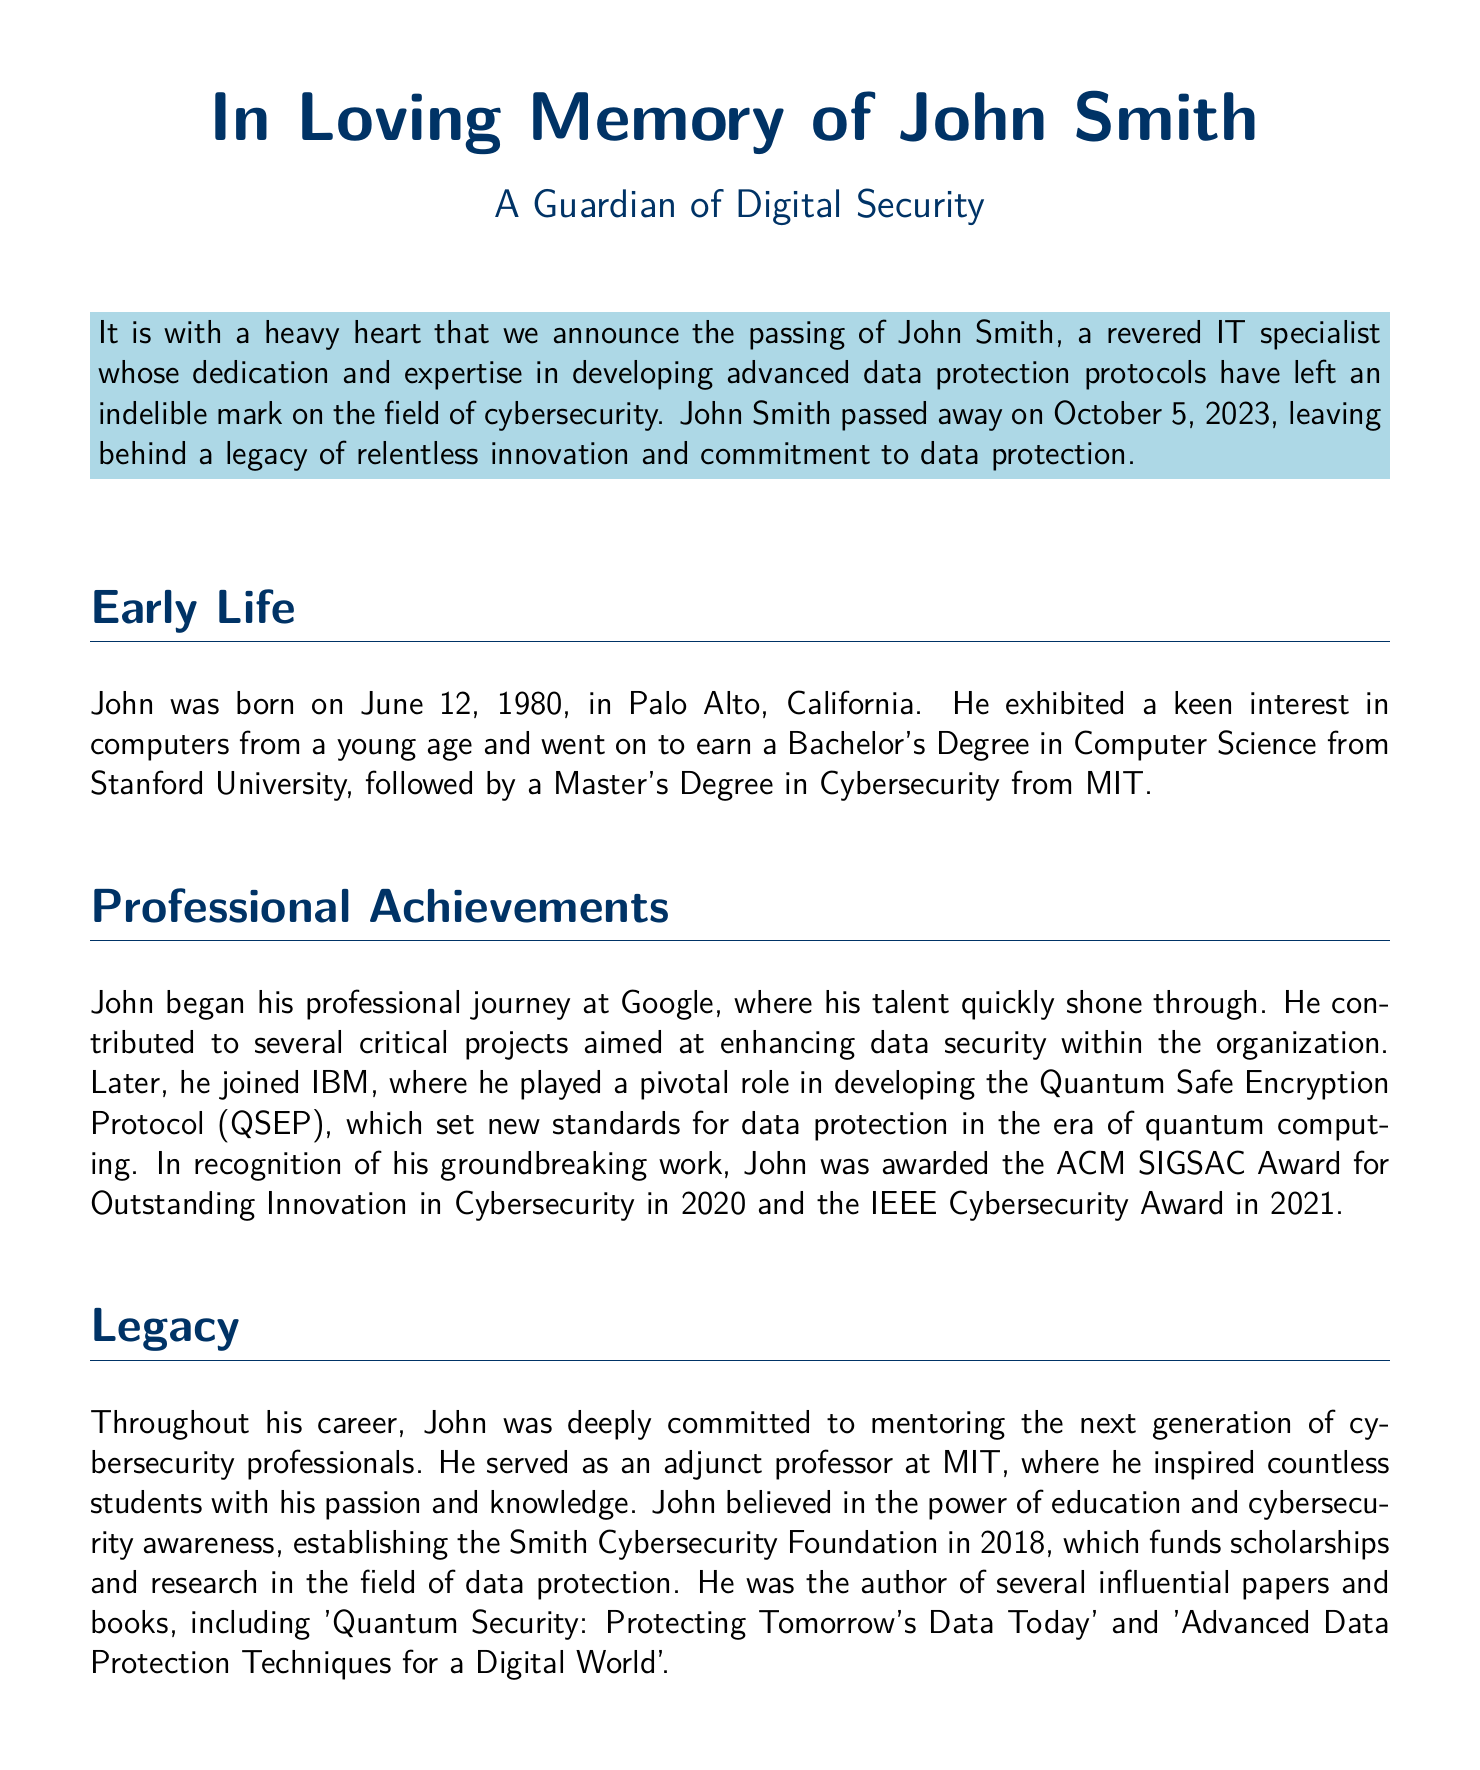What was John Smith's profession? John Smith is identified as an IT specialist in the document.
Answer: IT specialist When was John Smith born? The document states that John was born on June 12, 1980.
Answer: June 12, 1980 What significant protocol did John help develop at IBM? The document mentions the Quantum Safe Encryption Protocol (QSEP).
Answer: Quantum Safe Encryption Protocol (QSEP) Which awards did John receive for his work in cybersecurity? The document lists the ACM SIGSAC Award and the IEEE Cybersecurity Award as his achievements.
Answer: ACM SIGSAC Award, IEEE Cybersecurity Award What was the name of the foundation established by John? The document refers to the Smith Cybersecurity Foundation that John established.
Answer: Smith Cybersecurity Foundation Who survived John Smith? The document notes that he is survived by his wife Sarah and their two children.
Answer: Sarah, Emily, and Michael What did John believe in regarding education? According to the document, John believed in the power of education and cybersecurity awareness.
Answer: Power of education and cybersecurity awareness In what year did John establish his foundation? The document states that he established the foundation in 2018.
Answer: 2018 What was the title of one of John's influential books? The document indicates that one of his books is titled 'Quantum Security: Protecting Tomorrow's Data Today.'
Answer: Quantum Security: Protecting Tomorrow's Data Today 